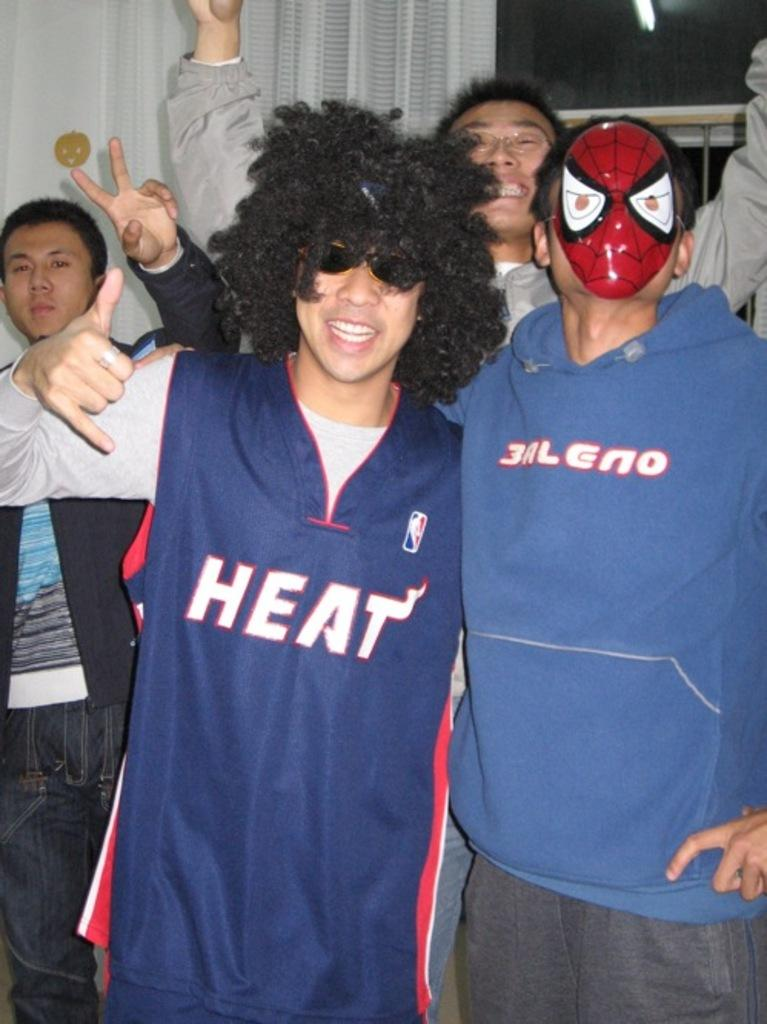<image>
Provide a brief description of the given image. A man in a Heat jersey poses with friends for a photo. 